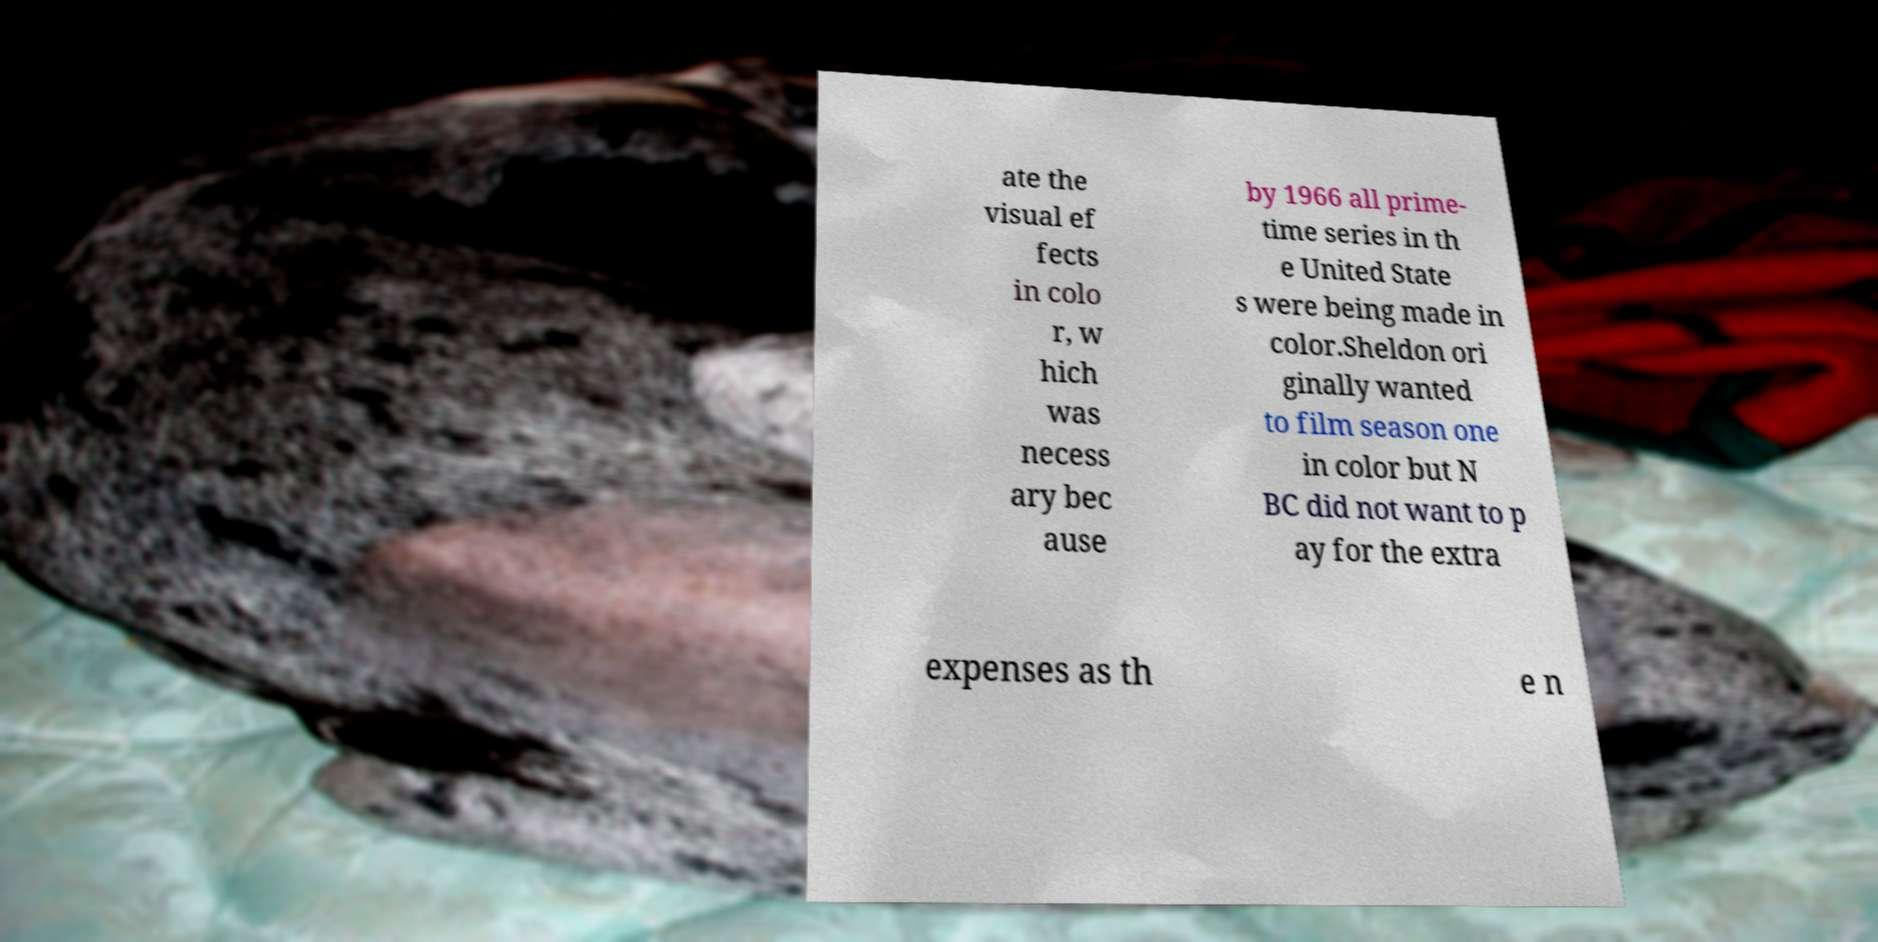I need the written content from this picture converted into text. Can you do that? ate the visual ef fects in colo r, w hich was necess ary bec ause by 1966 all prime- time series in th e United State s were being made in color.Sheldon ori ginally wanted to film season one in color but N BC did not want to p ay for the extra expenses as th e n 